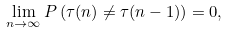<formula> <loc_0><loc_0><loc_500><loc_500>\lim _ { n \rightarrow \infty } P \left ( \tau ( n ) \neq \tau ( n - 1 ) \right ) = 0 ,</formula> 